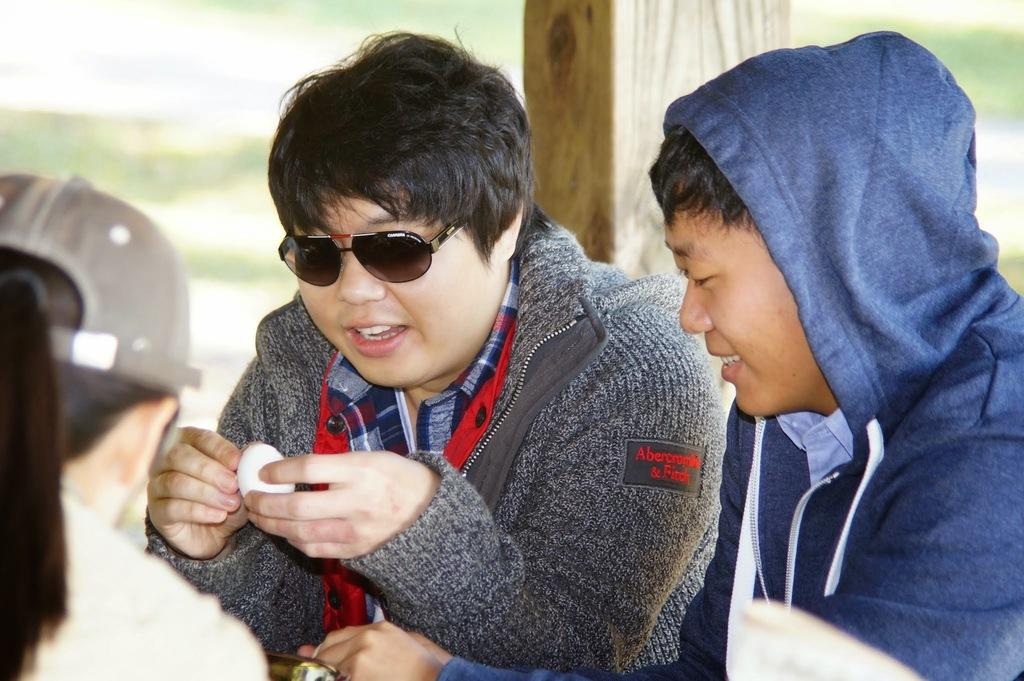How many people are in the image? There are three persons in the image. What is the man holding in the image? The man is holding an egg. What can be seen behind the people in the image? There is a wooden pole behind the people. Can you describe the background of the image? The background of the image is blurred. Is there a parcel being delivered in the image? There is no mention of a parcel in the image, so it cannot be determined if one is being delivered. Does the existence of the egg in the image prove the existence of life on other planets? The presence of an egg in the image does not provide any information about the existence of life on other planets. 